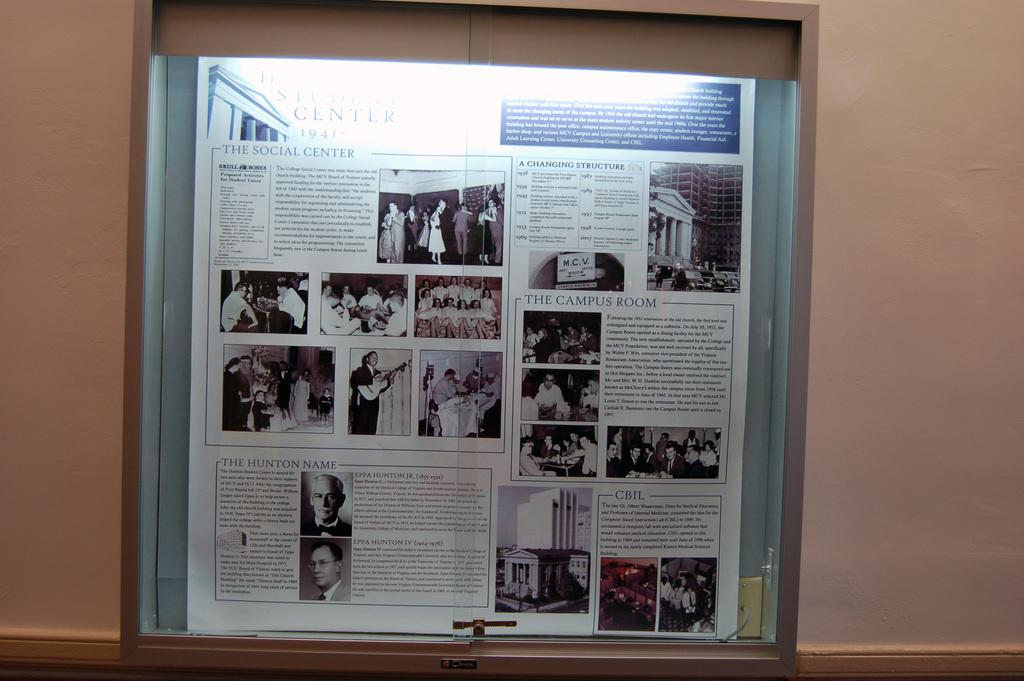Which center is this?
Offer a terse response. The social center. 